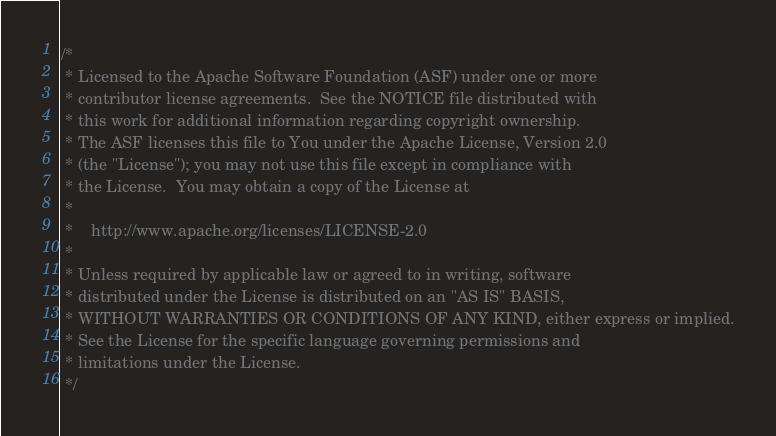Convert code to text. <code><loc_0><loc_0><loc_500><loc_500><_Java_>/*
 * Licensed to the Apache Software Foundation (ASF) under one or more
 * contributor license agreements.  See the NOTICE file distributed with
 * this work for additional information regarding copyright ownership.
 * The ASF licenses this file to You under the Apache License, Version 2.0
 * (the "License"); you may not use this file except in compliance with
 * the License.  You may obtain a copy of the License at
 *
 *    http://www.apache.org/licenses/LICENSE-2.0
 *
 * Unless required by applicable law or agreed to in writing, software
 * distributed under the License is distributed on an "AS IS" BASIS,
 * WITHOUT WARRANTIES OR CONDITIONS OF ANY KIND, either express or implied.
 * See the License for the specific language governing permissions and
 * limitations under the License.
 */
</code> 